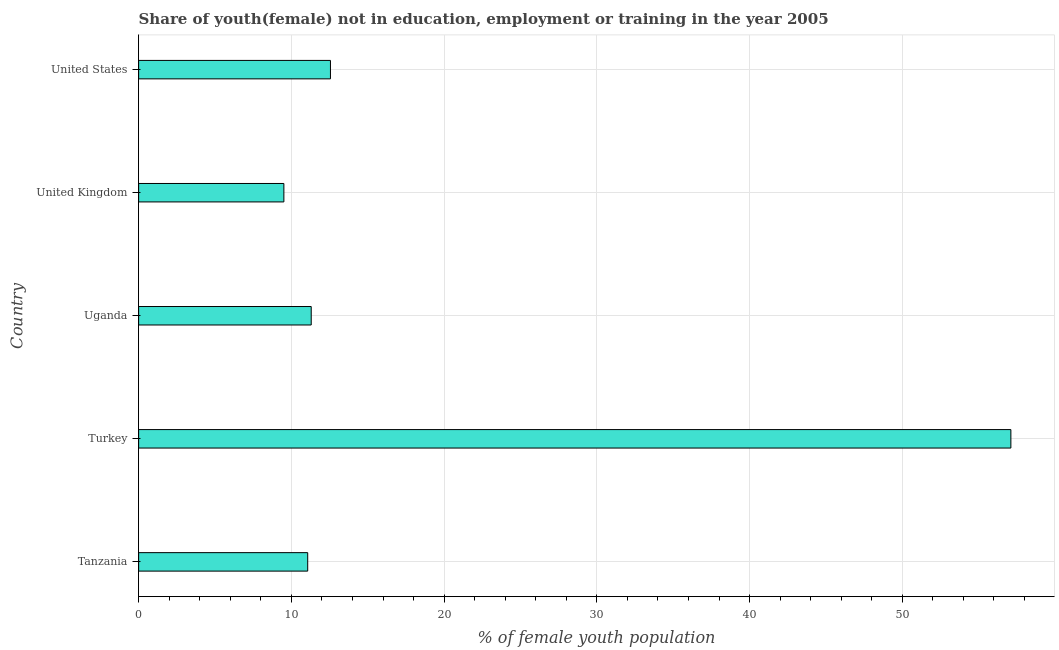Does the graph contain grids?
Offer a terse response. Yes. What is the title of the graph?
Provide a succinct answer. Share of youth(female) not in education, employment or training in the year 2005. What is the label or title of the X-axis?
Offer a very short reply. % of female youth population. What is the unemployed female youth population in Uganda?
Keep it short and to the point. 11.3. Across all countries, what is the maximum unemployed female youth population?
Make the answer very short. 57.11. Across all countries, what is the minimum unemployed female youth population?
Keep it short and to the point. 9.51. In which country was the unemployed female youth population maximum?
Keep it short and to the point. Turkey. What is the sum of the unemployed female youth population?
Give a very brief answer. 101.55. What is the difference between the unemployed female youth population in Uganda and United Kingdom?
Give a very brief answer. 1.79. What is the average unemployed female youth population per country?
Keep it short and to the point. 20.31. What is the median unemployed female youth population?
Provide a succinct answer. 11.3. In how many countries, is the unemployed female youth population greater than 32 %?
Offer a terse response. 1. What is the ratio of the unemployed female youth population in Turkey to that in Uganda?
Offer a terse response. 5.05. What is the difference between the highest and the second highest unemployed female youth population?
Provide a succinct answer. 44.55. What is the difference between the highest and the lowest unemployed female youth population?
Give a very brief answer. 47.6. In how many countries, is the unemployed female youth population greater than the average unemployed female youth population taken over all countries?
Give a very brief answer. 1. How many bars are there?
Offer a very short reply. 5. Are all the bars in the graph horizontal?
Your response must be concise. Yes. What is the % of female youth population of Tanzania?
Offer a very short reply. 11.07. What is the % of female youth population of Turkey?
Provide a short and direct response. 57.11. What is the % of female youth population in Uganda?
Make the answer very short. 11.3. What is the % of female youth population in United Kingdom?
Your answer should be compact. 9.51. What is the % of female youth population in United States?
Give a very brief answer. 12.56. What is the difference between the % of female youth population in Tanzania and Turkey?
Your answer should be very brief. -46.04. What is the difference between the % of female youth population in Tanzania and Uganda?
Your answer should be compact. -0.23. What is the difference between the % of female youth population in Tanzania and United Kingdom?
Your answer should be compact. 1.56. What is the difference between the % of female youth population in Tanzania and United States?
Your answer should be compact. -1.49. What is the difference between the % of female youth population in Turkey and Uganda?
Your response must be concise. 45.81. What is the difference between the % of female youth population in Turkey and United Kingdom?
Your response must be concise. 47.6. What is the difference between the % of female youth population in Turkey and United States?
Offer a terse response. 44.55. What is the difference between the % of female youth population in Uganda and United Kingdom?
Keep it short and to the point. 1.79. What is the difference between the % of female youth population in Uganda and United States?
Make the answer very short. -1.26. What is the difference between the % of female youth population in United Kingdom and United States?
Your response must be concise. -3.05. What is the ratio of the % of female youth population in Tanzania to that in Turkey?
Your answer should be very brief. 0.19. What is the ratio of the % of female youth population in Tanzania to that in United Kingdom?
Give a very brief answer. 1.16. What is the ratio of the % of female youth population in Tanzania to that in United States?
Your answer should be compact. 0.88. What is the ratio of the % of female youth population in Turkey to that in Uganda?
Provide a succinct answer. 5.05. What is the ratio of the % of female youth population in Turkey to that in United Kingdom?
Your answer should be very brief. 6. What is the ratio of the % of female youth population in Turkey to that in United States?
Your response must be concise. 4.55. What is the ratio of the % of female youth population in Uganda to that in United Kingdom?
Offer a terse response. 1.19. What is the ratio of the % of female youth population in United Kingdom to that in United States?
Keep it short and to the point. 0.76. 